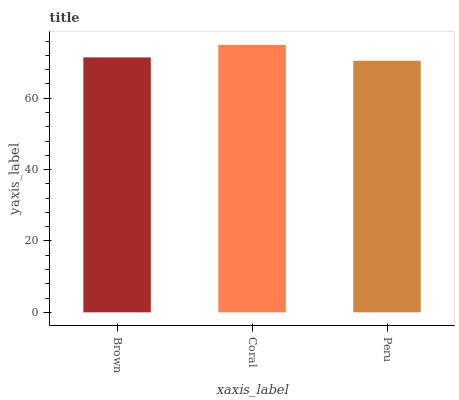Is Peru the minimum?
Answer yes or no. Yes. Is Coral the maximum?
Answer yes or no. Yes. Is Coral the minimum?
Answer yes or no. No. Is Peru the maximum?
Answer yes or no. No. Is Coral greater than Peru?
Answer yes or no. Yes. Is Peru less than Coral?
Answer yes or no. Yes. Is Peru greater than Coral?
Answer yes or no. No. Is Coral less than Peru?
Answer yes or no. No. Is Brown the high median?
Answer yes or no. Yes. Is Brown the low median?
Answer yes or no. Yes. Is Peru the high median?
Answer yes or no. No. Is Coral the low median?
Answer yes or no. No. 